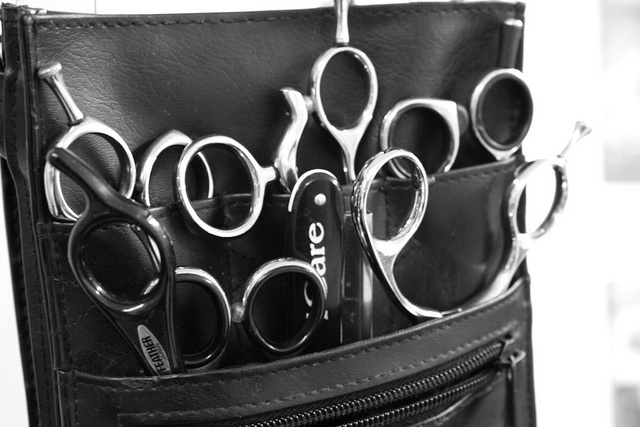Describe the objects in this image and their specific colors. I can see scissors in white, black, gray, and darkgray tones, scissors in white, black, gray, and darkgray tones, scissors in white, black, gray, and darkgray tones, scissors in white, black, gray, lightgray, and darkgray tones, and scissors in white, black, gray, and darkgray tones in this image. 